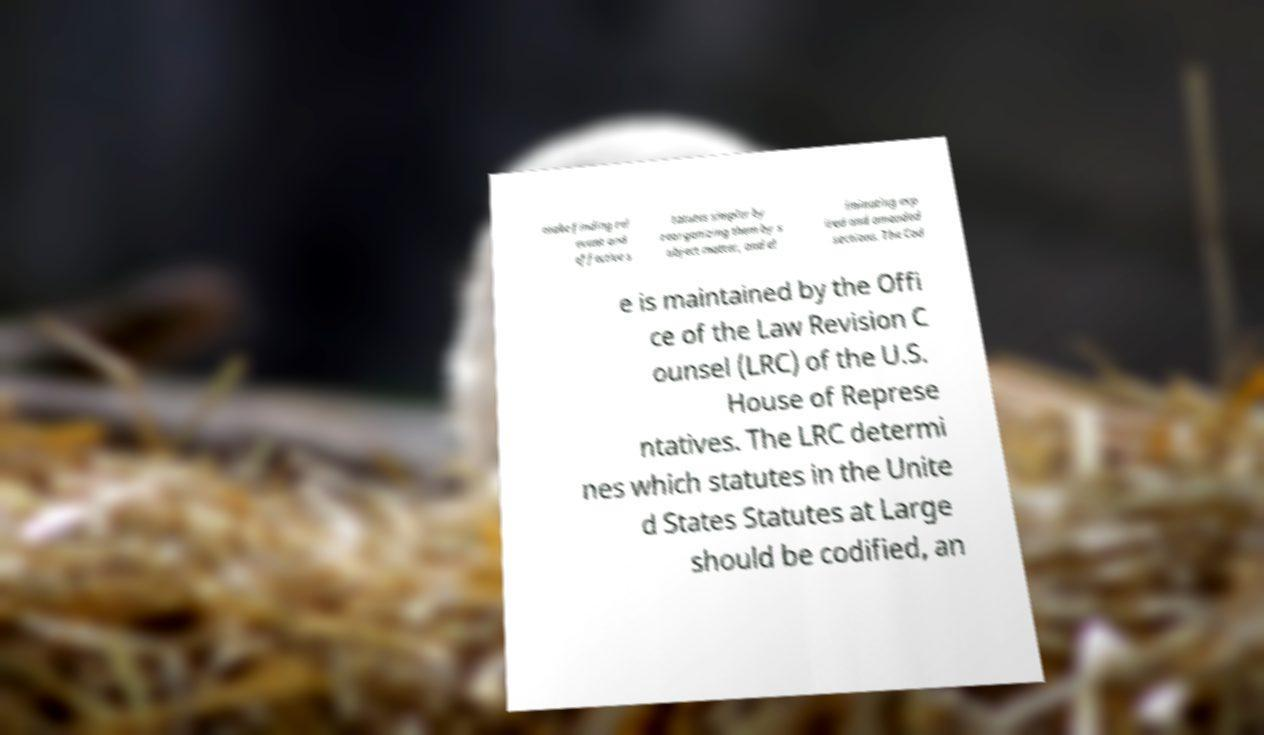Can you accurately transcribe the text from the provided image for me? make finding rel evant and effective s tatutes simpler by reorganizing them by s ubject matter, and el iminating exp ired and amended sections. The Cod e is maintained by the Offi ce of the Law Revision C ounsel (LRC) of the U.S. House of Represe ntatives. The LRC determi nes which statutes in the Unite d States Statutes at Large should be codified, an 